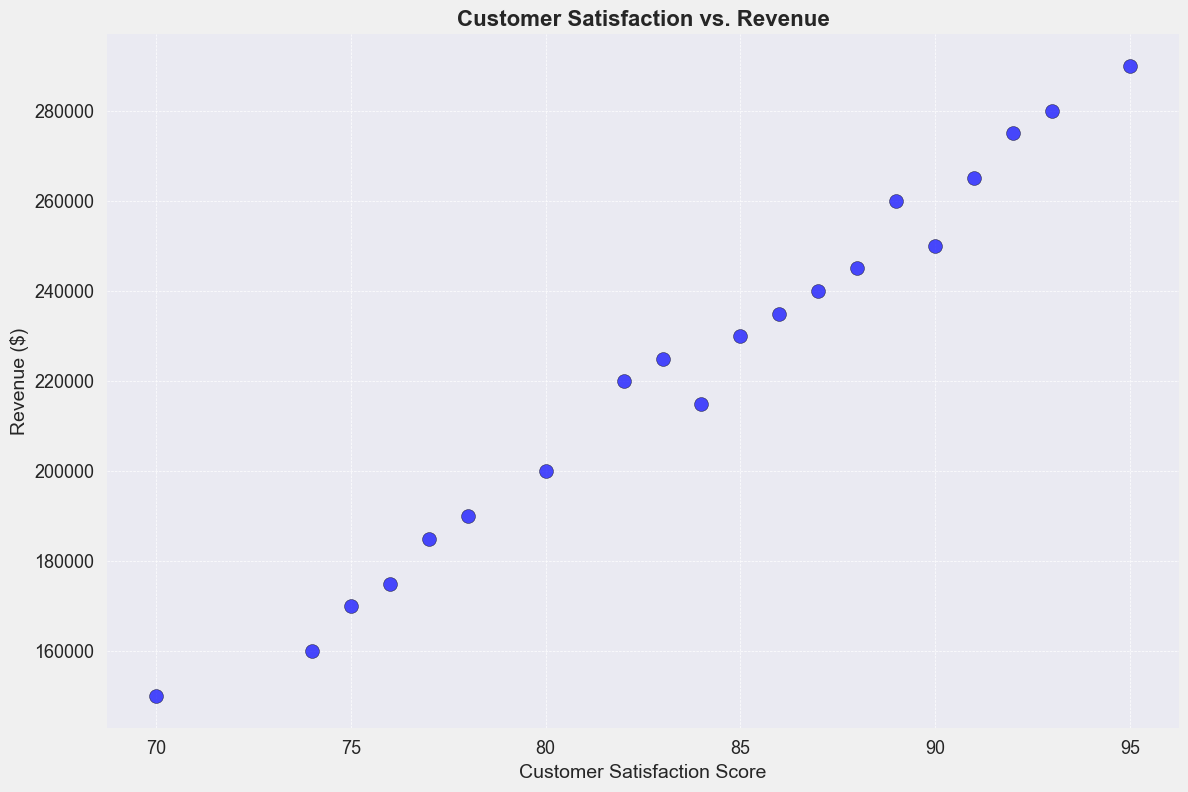What's the customer satisfaction score of the eatery with the highest revenue? Find the point with the highest position on the y-axis, then check the corresponding x-axis value for that point. The eatery with the highest revenue ($290,000) corresponds to a customer satisfaction score of 95.
Answer: 95 Which eatery has a higher revenue, Eatery D or Eatery F? Compare the y-axis values for Eatery D and Eatery F. Eatery D has a revenue of $160,000, and Eatery F has a revenue of $275,000.
Answer: Eatery F What is the average revenue of the eateries with customer satisfaction scores above 90? Identify the eateries with customer satisfaction scores above 90 (Eatery F, Eatery P, Eatery T, Eatery M). Their revenues are $275,000, $265,000, $280,000, and $290,000. Sum them up: 275,000 + 265,000 + 280,000 + 290,000 = $1,110,000. Now, divide by 4.
Answer: $277,500 What is the difference in revenue between the eatery with the highest customer satisfaction score and the eatery with the lowest customer satisfaction score? Identify the highest and lowest customer satisfaction scores (95 and 70, respectively). The revenues for these are $290,000 and $150,000. Calculate the difference: 290,000 - 150,000.
Answer: $140,000 Is there a positive correlation between customer satisfaction scores and revenue across the eateries? Visually assess if points trend upwards from left to right on the scatter plot. Generally, higher satisfaction scores align with higher revenues.
Answer: Yes 